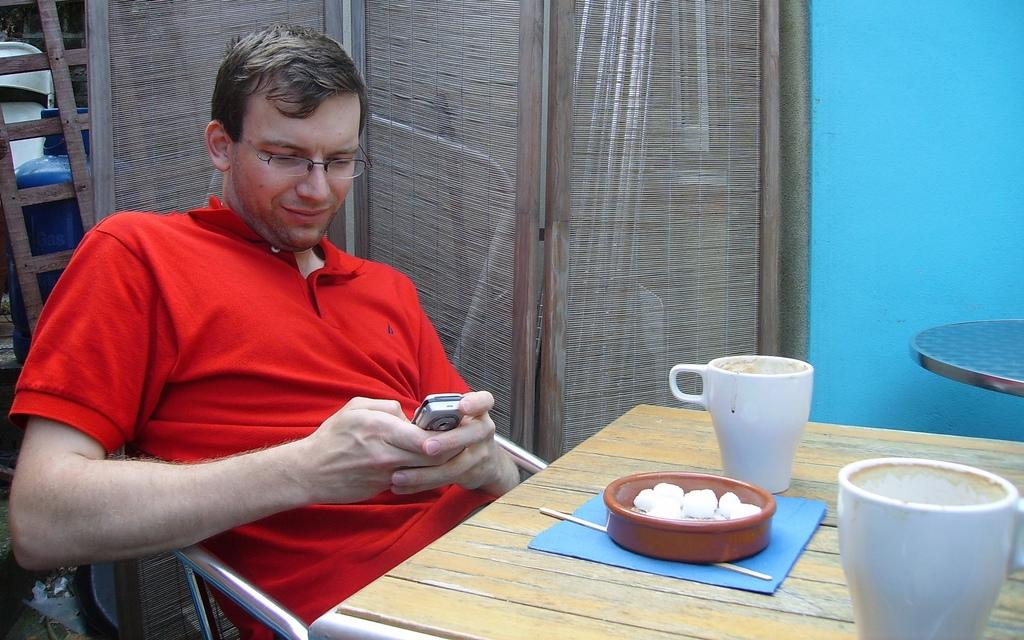Who is present in the image? There is a man in the image. What is the man doing in the image? The man is sitting on a chair. What is the man wearing in the image? The man is wearing a red t-shirt. What is in front of the man? There is a table in front of the man. What can be seen on the table? There is a tea cup on the table, and there are other objects on the table as well. What can be seen in the background of the image? There is a wall visible in the image. What type of plant is the man watering with a rake in the image? There is no plant or rake present in the image. Can you tell me how the man's mother is feeling in the image? There is no mention of the man's mother in the image, so it is not possible to determine her feelings. 